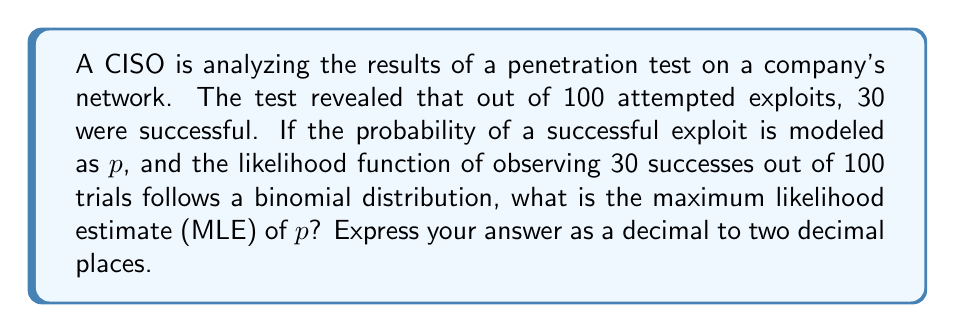Solve this math problem. To solve this inverse problem, we'll follow these steps:

1) The likelihood function for a binomial distribution is:

   $$L(p|x) = \binom{n}{x} p^x (1-p)^{n-x}$$

   where $n$ is the number of trials, $x$ is the number of successes, and $p$ is the probability of success.

2) In this case, $n = 100$ and $x = 30$.

3) To find the MLE, we need to maximize $L(p|x)$ with respect to $p$. This is equivalent to maximizing the log-likelihood:

   $$\ln L(p|x) = \ln \binom{n}{x} + x \ln p + (n-x) \ln(1-p)$$

4) We differentiate this with respect to $p$ and set it to zero:

   $$\frac{d}{dp} \ln L(p|x) = \frac{x}{p} - \frac{n-x}{1-p} = 0$$

5) Solving this equation:

   $$\frac{x}{p} = \frac{n-x}{1-p}$$
   $$x(1-p) = p(n-x)$$
   $$x - xp = np - xp$$
   $$x = np$$
   $$p = \frac{x}{n}$$

6) Substituting our values:

   $$p = \frac{30}{100} = 0.30$$

Therefore, the maximum likelihood estimate of $p$ is 0.30.
Answer: 0.30 